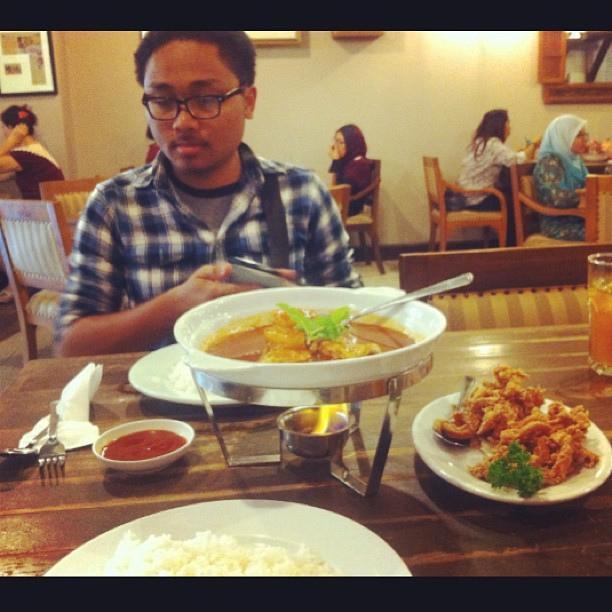How many people can you see?
Give a very brief answer. 5. How many chairs are there?
Give a very brief answer. 4. How many bowls are there?
Give a very brief answer. 3. How many train segments are visible?
Give a very brief answer. 0. 